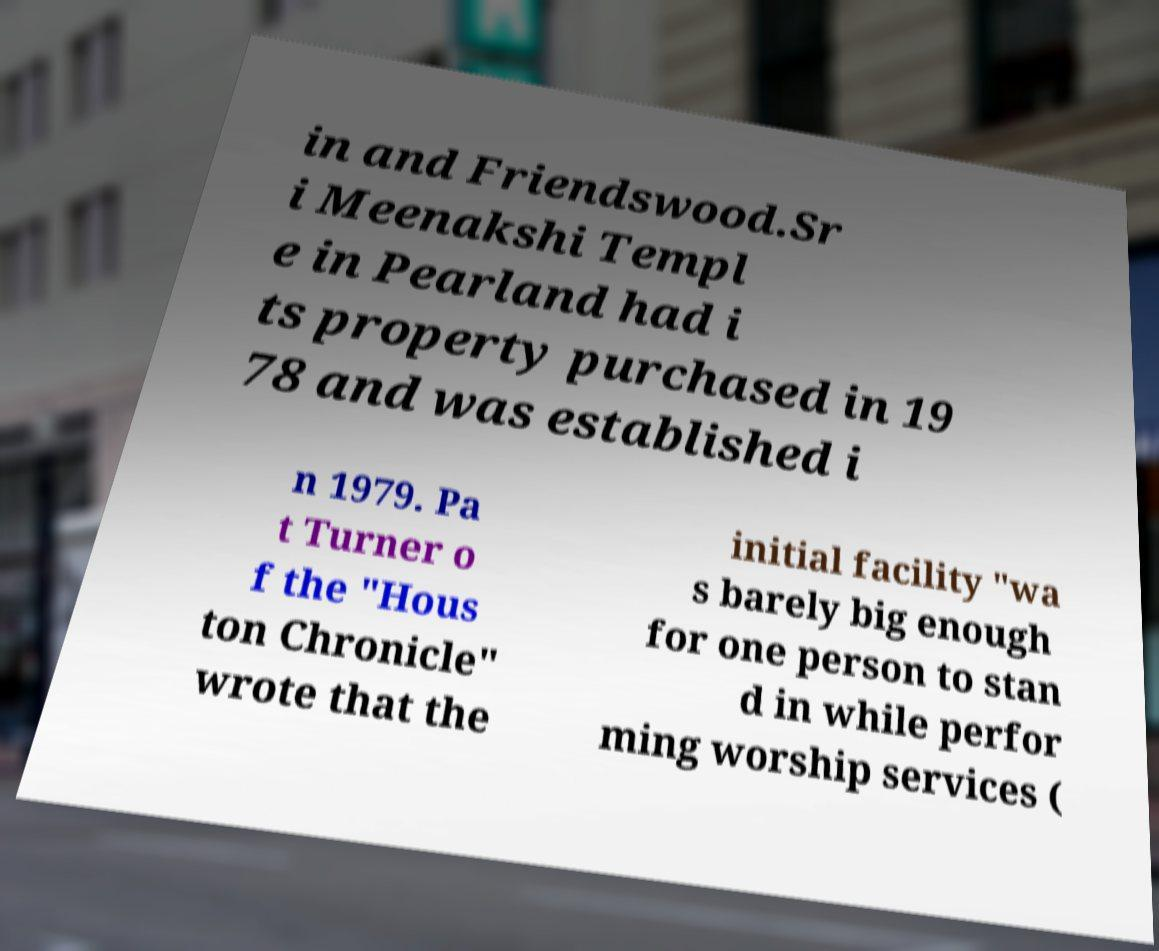Can you read and provide the text displayed in the image?This photo seems to have some interesting text. Can you extract and type it out for me? in and Friendswood.Sr i Meenakshi Templ e in Pearland had i ts property purchased in 19 78 and was established i n 1979. Pa t Turner o f the "Hous ton Chronicle" wrote that the initial facility "wa s barely big enough for one person to stan d in while perfor ming worship services ( 